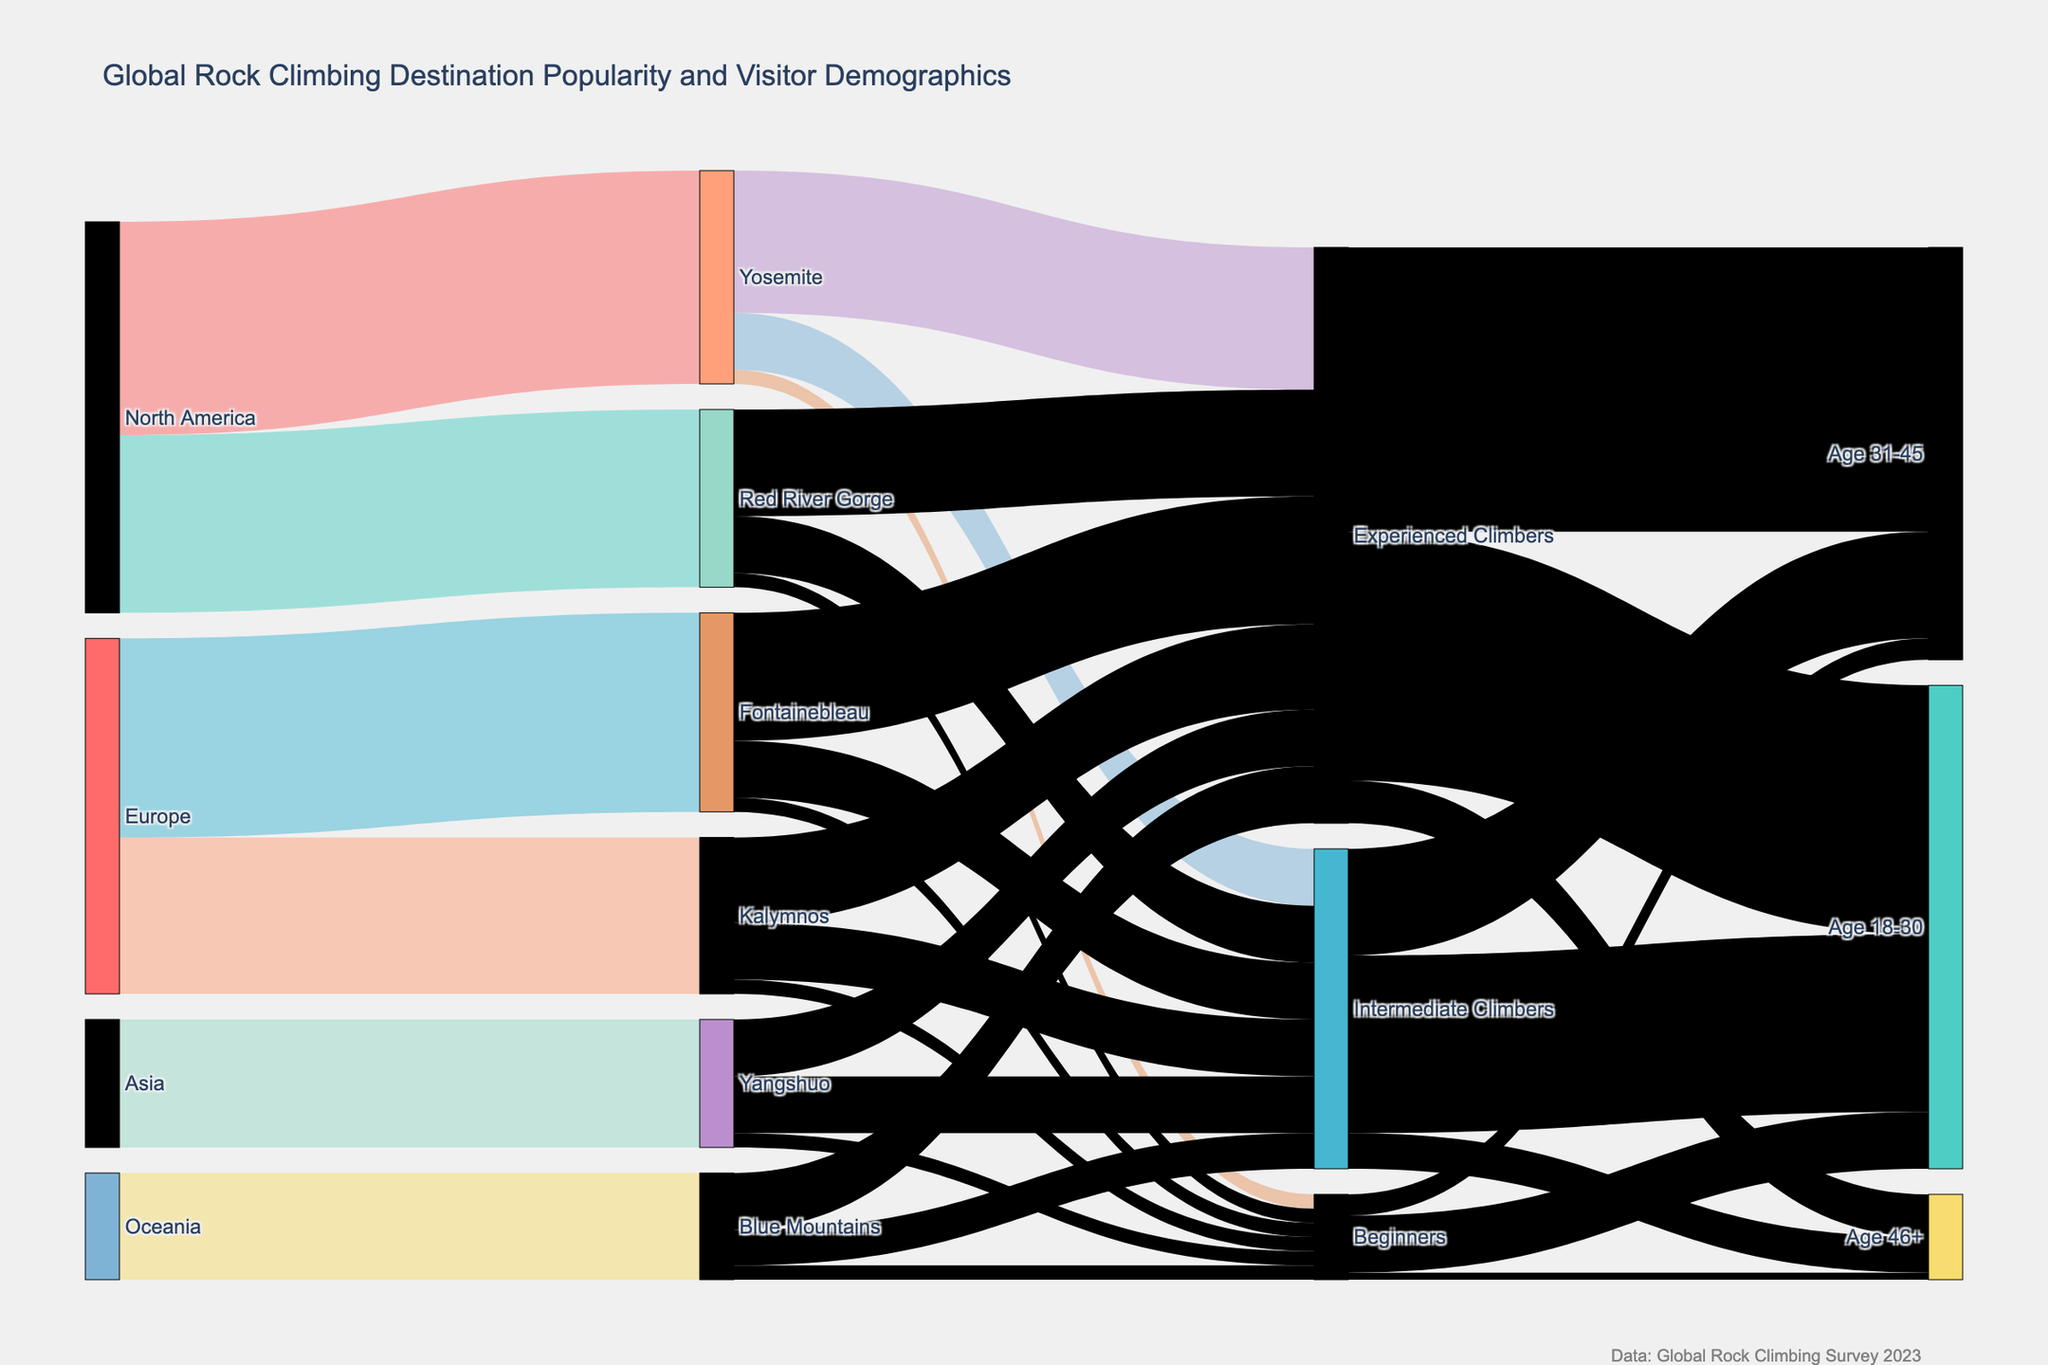Which destination in North America has more visitors: Yosemite or Red River Gorge? To determine the more popular destination within North America between Yosemite and Red River Gorge, compare their visitor counts from the "source" 'North America'. Yosemite has 30,000 visitors, and Red River Gorge has 25,000 visitors. Thus, Yosemite has more visitors.
Answer: Yosemite What's the total number of experienced climbers visiting all destinations? Add up the number of experienced climbers across all destinations: Yosemite (20,000), Red River Gorge (15,000), Fontainebleau (18,000), Kalymnos (12,000), Yangshuo (8,000), and Blue Mountains (8,000). The sum is 20,000 + 15,000 + 18,000 + 12,000 + 8,000 + 8,000 = 81,000.
Answer: 81,000 Which climbing destination in Europe attracts the most visitors? To find the most popular climbing destination in Europe, compare the visitor counts for Fontainebleau and Kalymnos. Fontainebleau has 28,000 visitors, while Kalymnos has 22,000 visitors. Thus, Fontainebleau attracts the most visitors.
Answer: Fontainebleau Are there more intermediate climbers visiting Yosemite or Fontainebleau? Compare the number of intermediate climbers for Yosemite and Fontainebleau. Yosemite has 8,000 intermediate climbers, and Fontainebleau also has 8,000 intermediate climbers. Therefore, the number is equal.
Answer: Equal What is the total number of visitors aged 18-30? Add the numbers of visitors aged 18-30 across all experience levels: Experienced Climbers (35,000), Intermediate Climbers (25,000), and Beginners (8,000). The sum is 35,000 + 25,000 + 8,000 = 68,000.
Answer: 68,000 How many visitors are beginners aged 46+? From the diagram, the "Beginners" group has an age segment "46+" with 1,000 visitors.
Answer: 1,000 Which age group has the highest number of experienced climbers? Compare the number of experienced climbers by age groups: Age 18-30 (35,000), Age 31-45 (40,000), and Age 46+ (6,000). The highest number is in the Age 31-45 group with 40,000 experienced climbers.
Answer: Age 31-45 How many visitors are intermediate climbers visiting the Blue Mountains? From the diagram, Blue Mountains has 5,000 intermediate climbers.
Answer: 5,000 Does Kalymnos attract more or fewer intermediate climbers than Yangshuo? Compare the intermediate climbers for Kalymnos and Yangshuo. Both Kalymnos and Yangshuo have 8,000 intermediate climbers, so they attract an equal number.
Answer: Equal 